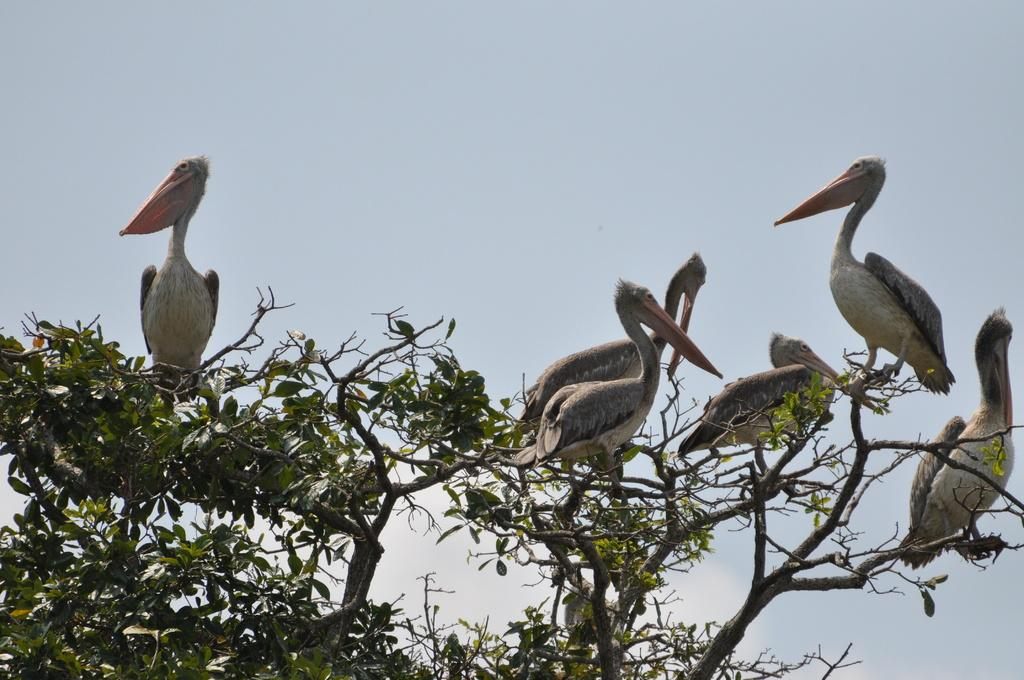What type of animals can be seen in the image? There are birds in the image. Where are the birds located in the image? The birds are sitting on a tree. What can be seen in the background of the image? The sky is visible in the background of the image. What type of business is being conducted by the birds in the image? There is no indication of any business being conducted by the birds in the image. 